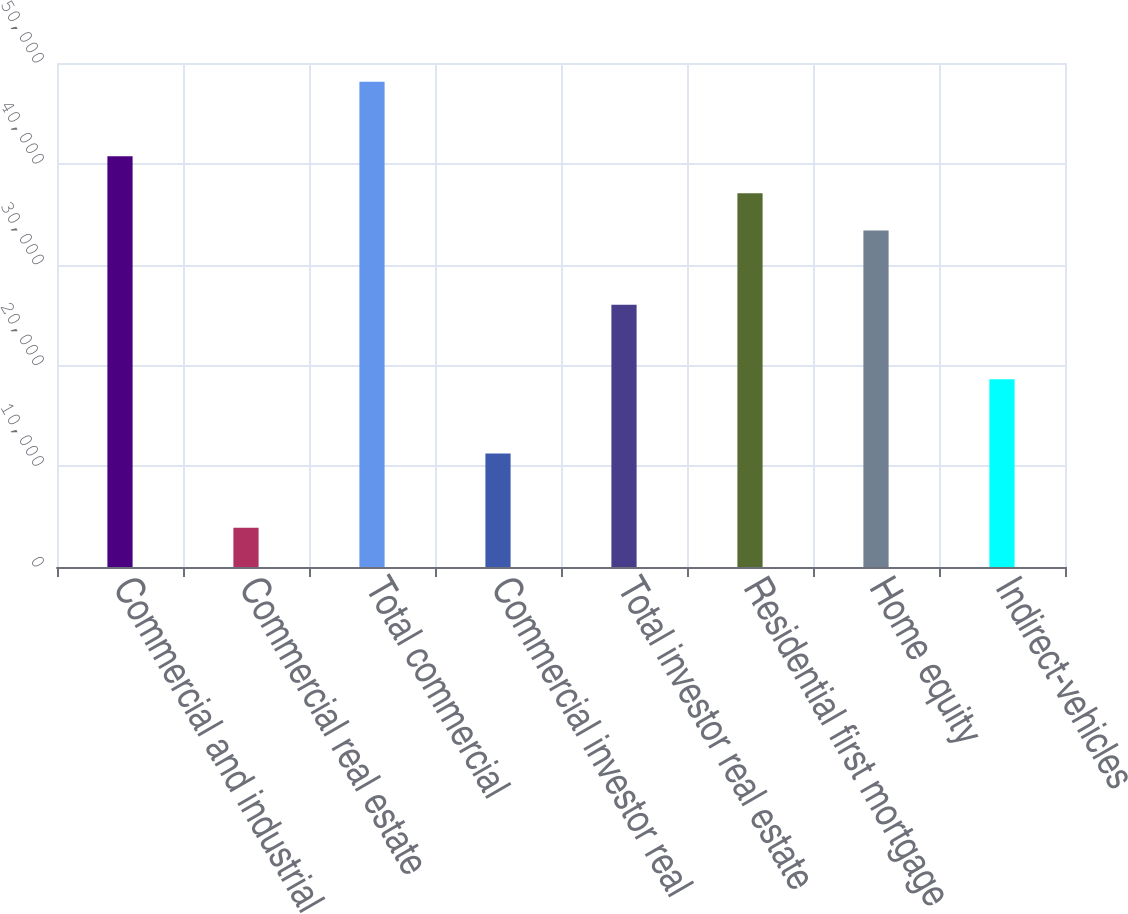Convert chart to OTSL. <chart><loc_0><loc_0><loc_500><loc_500><bar_chart><fcel>Commercial and industrial<fcel>Commercial real estate<fcel>Total commercial<fcel>Commercial investor real<fcel>Total investor real estate<fcel>Residential first mortgage<fcel>Home equity<fcel>Indirect-vehicles<nl><fcel>40758.4<fcel>3884.4<fcel>48133.2<fcel>11259.2<fcel>26008.8<fcel>37071<fcel>33383.6<fcel>18634<nl></chart> 